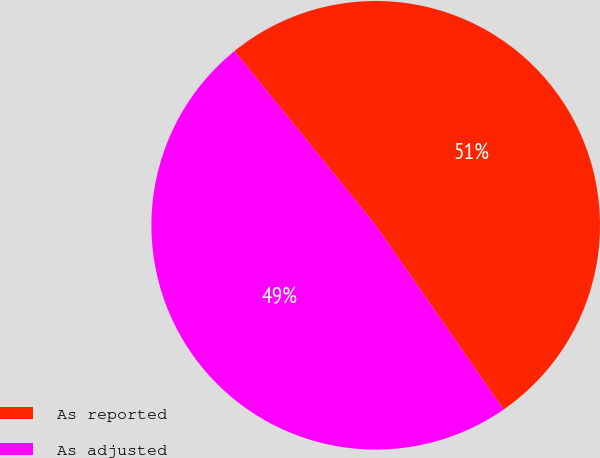<chart> <loc_0><loc_0><loc_500><loc_500><pie_chart><fcel>As reported<fcel>As adjusted<nl><fcel>51.19%<fcel>48.81%<nl></chart> 